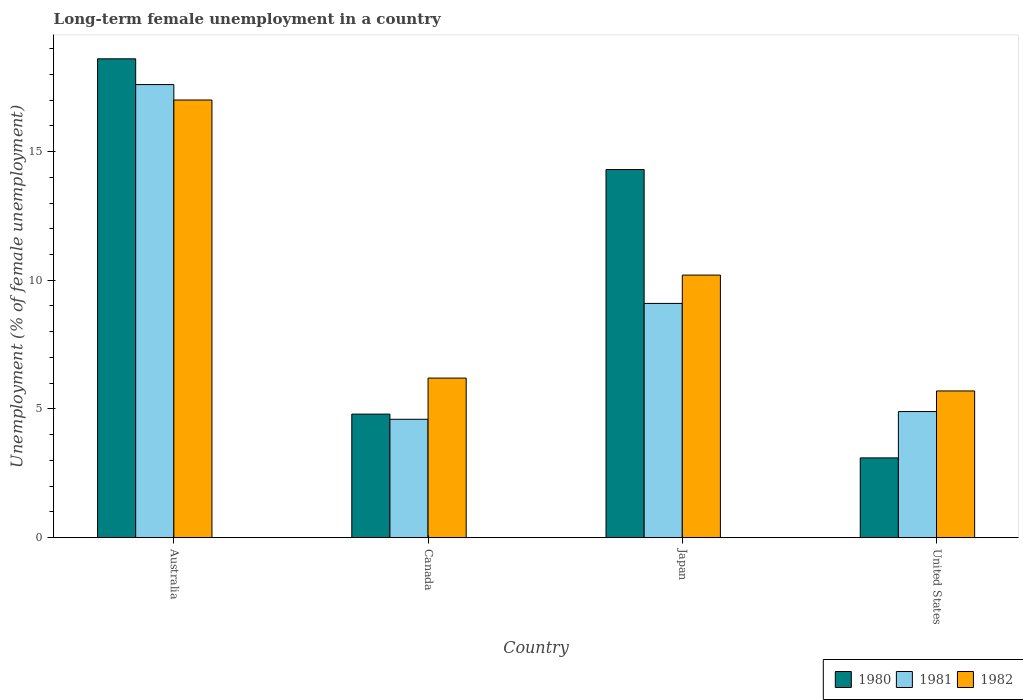How many groups of bars are there?
Offer a terse response. 4. Are the number of bars per tick equal to the number of legend labels?
Ensure brevity in your answer.  Yes. How many bars are there on the 4th tick from the right?
Your answer should be compact. 3. In how many cases, is the number of bars for a given country not equal to the number of legend labels?
Give a very brief answer. 0. What is the percentage of long-term unemployed female population in 1980 in Japan?
Offer a very short reply. 14.3. Across all countries, what is the minimum percentage of long-term unemployed female population in 1982?
Make the answer very short. 5.7. What is the total percentage of long-term unemployed female population in 1981 in the graph?
Provide a short and direct response. 36.2. What is the difference between the percentage of long-term unemployed female population in 1981 in Canada and that in United States?
Offer a very short reply. -0.3. What is the difference between the percentage of long-term unemployed female population in 1980 in Japan and the percentage of long-term unemployed female population in 1982 in Australia?
Offer a terse response. -2.7. What is the average percentage of long-term unemployed female population in 1982 per country?
Your response must be concise. 9.77. What is the difference between the percentage of long-term unemployed female population of/in 1980 and percentage of long-term unemployed female population of/in 1981 in Japan?
Ensure brevity in your answer.  5.2. What is the ratio of the percentage of long-term unemployed female population in 1982 in Japan to that in United States?
Offer a terse response. 1.79. What is the difference between the highest and the second highest percentage of long-term unemployed female population in 1981?
Keep it short and to the point. 12.7. What is the difference between the highest and the lowest percentage of long-term unemployed female population in 1981?
Your answer should be compact. 13. In how many countries, is the percentage of long-term unemployed female population in 1980 greater than the average percentage of long-term unemployed female population in 1980 taken over all countries?
Keep it short and to the point. 2. How many bars are there?
Provide a short and direct response. 12. Are all the bars in the graph horizontal?
Your response must be concise. No. How many countries are there in the graph?
Provide a short and direct response. 4. What is the difference between two consecutive major ticks on the Y-axis?
Make the answer very short. 5. Are the values on the major ticks of Y-axis written in scientific E-notation?
Offer a terse response. No. Does the graph contain any zero values?
Give a very brief answer. No. Does the graph contain grids?
Your answer should be compact. No. How many legend labels are there?
Keep it short and to the point. 3. How are the legend labels stacked?
Keep it short and to the point. Horizontal. What is the title of the graph?
Your answer should be compact. Long-term female unemployment in a country. Does "1964" appear as one of the legend labels in the graph?
Your answer should be very brief. No. What is the label or title of the X-axis?
Ensure brevity in your answer.  Country. What is the label or title of the Y-axis?
Offer a very short reply. Unemployment (% of female unemployment). What is the Unemployment (% of female unemployment) of 1980 in Australia?
Keep it short and to the point. 18.6. What is the Unemployment (% of female unemployment) of 1981 in Australia?
Offer a very short reply. 17.6. What is the Unemployment (% of female unemployment) in 1980 in Canada?
Your answer should be very brief. 4.8. What is the Unemployment (% of female unemployment) of 1981 in Canada?
Keep it short and to the point. 4.6. What is the Unemployment (% of female unemployment) in 1982 in Canada?
Offer a terse response. 6.2. What is the Unemployment (% of female unemployment) in 1980 in Japan?
Provide a succinct answer. 14.3. What is the Unemployment (% of female unemployment) of 1981 in Japan?
Make the answer very short. 9.1. What is the Unemployment (% of female unemployment) of 1982 in Japan?
Provide a succinct answer. 10.2. What is the Unemployment (% of female unemployment) of 1980 in United States?
Make the answer very short. 3.1. What is the Unemployment (% of female unemployment) in 1981 in United States?
Provide a succinct answer. 4.9. What is the Unemployment (% of female unemployment) in 1982 in United States?
Offer a very short reply. 5.7. Across all countries, what is the maximum Unemployment (% of female unemployment) of 1980?
Keep it short and to the point. 18.6. Across all countries, what is the maximum Unemployment (% of female unemployment) in 1981?
Your answer should be compact. 17.6. Across all countries, what is the maximum Unemployment (% of female unemployment) of 1982?
Your answer should be very brief. 17. Across all countries, what is the minimum Unemployment (% of female unemployment) of 1980?
Offer a very short reply. 3.1. Across all countries, what is the minimum Unemployment (% of female unemployment) in 1981?
Make the answer very short. 4.6. Across all countries, what is the minimum Unemployment (% of female unemployment) of 1982?
Give a very brief answer. 5.7. What is the total Unemployment (% of female unemployment) of 1980 in the graph?
Your answer should be very brief. 40.8. What is the total Unemployment (% of female unemployment) in 1981 in the graph?
Your answer should be compact. 36.2. What is the total Unemployment (% of female unemployment) in 1982 in the graph?
Your answer should be compact. 39.1. What is the difference between the Unemployment (% of female unemployment) of 1981 in Australia and that in Canada?
Keep it short and to the point. 13. What is the difference between the Unemployment (% of female unemployment) of 1980 in Australia and that in Japan?
Your answer should be compact. 4.3. What is the difference between the Unemployment (% of female unemployment) of 1982 in Australia and that in United States?
Ensure brevity in your answer.  11.3. What is the difference between the Unemployment (% of female unemployment) of 1981 in Canada and that in Japan?
Provide a succinct answer. -4.5. What is the difference between the Unemployment (% of female unemployment) of 1982 in Canada and that in Japan?
Your answer should be very brief. -4. What is the difference between the Unemployment (% of female unemployment) of 1981 in Canada and that in United States?
Your answer should be very brief. -0.3. What is the difference between the Unemployment (% of female unemployment) of 1982 in Canada and that in United States?
Keep it short and to the point. 0.5. What is the difference between the Unemployment (% of female unemployment) in 1980 in Japan and that in United States?
Your answer should be compact. 11.2. What is the difference between the Unemployment (% of female unemployment) of 1982 in Japan and that in United States?
Offer a very short reply. 4.5. What is the difference between the Unemployment (% of female unemployment) of 1980 in Australia and the Unemployment (% of female unemployment) of 1981 in Canada?
Provide a succinct answer. 14. What is the difference between the Unemployment (% of female unemployment) in 1980 in Australia and the Unemployment (% of female unemployment) in 1982 in Japan?
Offer a very short reply. 8.4. What is the difference between the Unemployment (% of female unemployment) in 1981 in Australia and the Unemployment (% of female unemployment) in 1982 in Japan?
Provide a succinct answer. 7.4. What is the difference between the Unemployment (% of female unemployment) of 1980 in Australia and the Unemployment (% of female unemployment) of 1981 in United States?
Give a very brief answer. 13.7. What is the difference between the Unemployment (% of female unemployment) of 1980 in Australia and the Unemployment (% of female unemployment) of 1982 in United States?
Your answer should be very brief. 12.9. What is the difference between the Unemployment (% of female unemployment) of 1980 in Japan and the Unemployment (% of female unemployment) of 1982 in United States?
Offer a very short reply. 8.6. What is the difference between the Unemployment (% of female unemployment) in 1981 in Japan and the Unemployment (% of female unemployment) in 1982 in United States?
Ensure brevity in your answer.  3.4. What is the average Unemployment (% of female unemployment) in 1981 per country?
Offer a very short reply. 9.05. What is the average Unemployment (% of female unemployment) of 1982 per country?
Keep it short and to the point. 9.78. What is the difference between the Unemployment (% of female unemployment) in 1980 and Unemployment (% of female unemployment) in 1982 in Australia?
Give a very brief answer. 1.6. What is the difference between the Unemployment (% of female unemployment) of 1980 and Unemployment (% of female unemployment) of 1981 in Canada?
Keep it short and to the point. 0.2. What is the difference between the Unemployment (% of female unemployment) in 1980 and Unemployment (% of female unemployment) in 1982 in Canada?
Give a very brief answer. -1.4. What is the difference between the Unemployment (% of female unemployment) in 1981 and Unemployment (% of female unemployment) in 1982 in Canada?
Offer a terse response. -1.6. What is the difference between the Unemployment (% of female unemployment) in 1980 and Unemployment (% of female unemployment) in 1982 in Japan?
Provide a short and direct response. 4.1. What is the difference between the Unemployment (% of female unemployment) in 1980 and Unemployment (% of female unemployment) in 1982 in United States?
Make the answer very short. -2.6. What is the ratio of the Unemployment (% of female unemployment) in 1980 in Australia to that in Canada?
Provide a succinct answer. 3.88. What is the ratio of the Unemployment (% of female unemployment) in 1981 in Australia to that in Canada?
Keep it short and to the point. 3.83. What is the ratio of the Unemployment (% of female unemployment) of 1982 in Australia to that in Canada?
Your answer should be very brief. 2.74. What is the ratio of the Unemployment (% of female unemployment) in 1980 in Australia to that in Japan?
Provide a succinct answer. 1.3. What is the ratio of the Unemployment (% of female unemployment) of 1981 in Australia to that in Japan?
Provide a short and direct response. 1.93. What is the ratio of the Unemployment (% of female unemployment) of 1980 in Australia to that in United States?
Offer a very short reply. 6. What is the ratio of the Unemployment (% of female unemployment) in 1981 in Australia to that in United States?
Make the answer very short. 3.59. What is the ratio of the Unemployment (% of female unemployment) in 1982 in Australia to that in United States?
Your answer should be compact. 2.98. What is the ratio of the Unemployment (% of female unemployment) of 1980 in Canada to that in Japan?
Ensure brevity in your answer.  0.34. What is the ratio of the Unemployment (% of female unemployment) of 1981 in Canada to that in Japan?
Your answer should be compact. 0.51. What is the ratio of the Unemployment (% of female unemployment) of 1982 in Canada to that in Japan?
Offer a terse response. 0.61. What is the ratio of the Unemployment (% of female unemployment) of 1980 in Canada to that in United States?
Your answer should be compact. 1.55. What is the ratio of the Unemployment (% of female unemployment) of 1981 in Canada to that in United States?
Keep it short and to the point. 0.94. What is the ratio of the Unemployment (% of female unemployment) of 1982 in Canada to that in United States?
Provide a succinct answer. 1.09. What is the ratio of the Unemployment (% of female unemployment) of 1980 in Japan to that in United States?
Provide a short and direct response. 4.61. What is the ratio of the Unemployment (% of female unemployment) of 1981 in Japan to that in United States?
Your answer should be compact. 1.86. What is the ratio of the Unemployment (% of female unemployment) in 1982 in Japan to that in United States?
Your answer should be compact. 1.79. What is the difference between the highest and the second highest Unemployment (% of female unemployment) of 1980?
Your response must be concise. 4.3. What is the difference between the highest and the second highest Unemployment (% of female unemployment) of 1981?
Offer a very short reply. 8.5. What is the difference between the highest and the lowest Unemployment (% of female unemployment) of 1980?
Your answer should be very brief. 15.5. What is the difference between the highest and the lowest Unemployment (% of female unemployment) in 1982?
Provide a short and direct response. 11.3. 